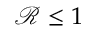<formula> <loc_0><loc_0><loc_500><loc_500>\mathcal { R } \leq 1</formula> 